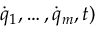<formula> <loc_0><loc_0><loc_500><loc_500>{ \dot { q } } _ { 1 } , \dots , { \dot { q } } _ { m } , t )</formula> 